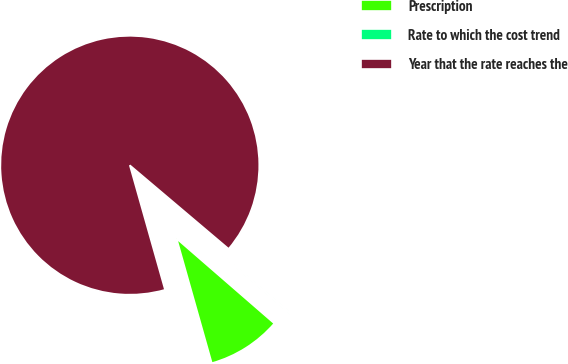<chart> <loc_0><loc_0><loc_500><loc_500><pie_chart><fcel>Prescription<fcel>Rate to which the cost trend<fcel>Year that the rate reaches the<nl><fcel>9.24%<fcel>0.2%<fcel>90.56%<nl></chart> 